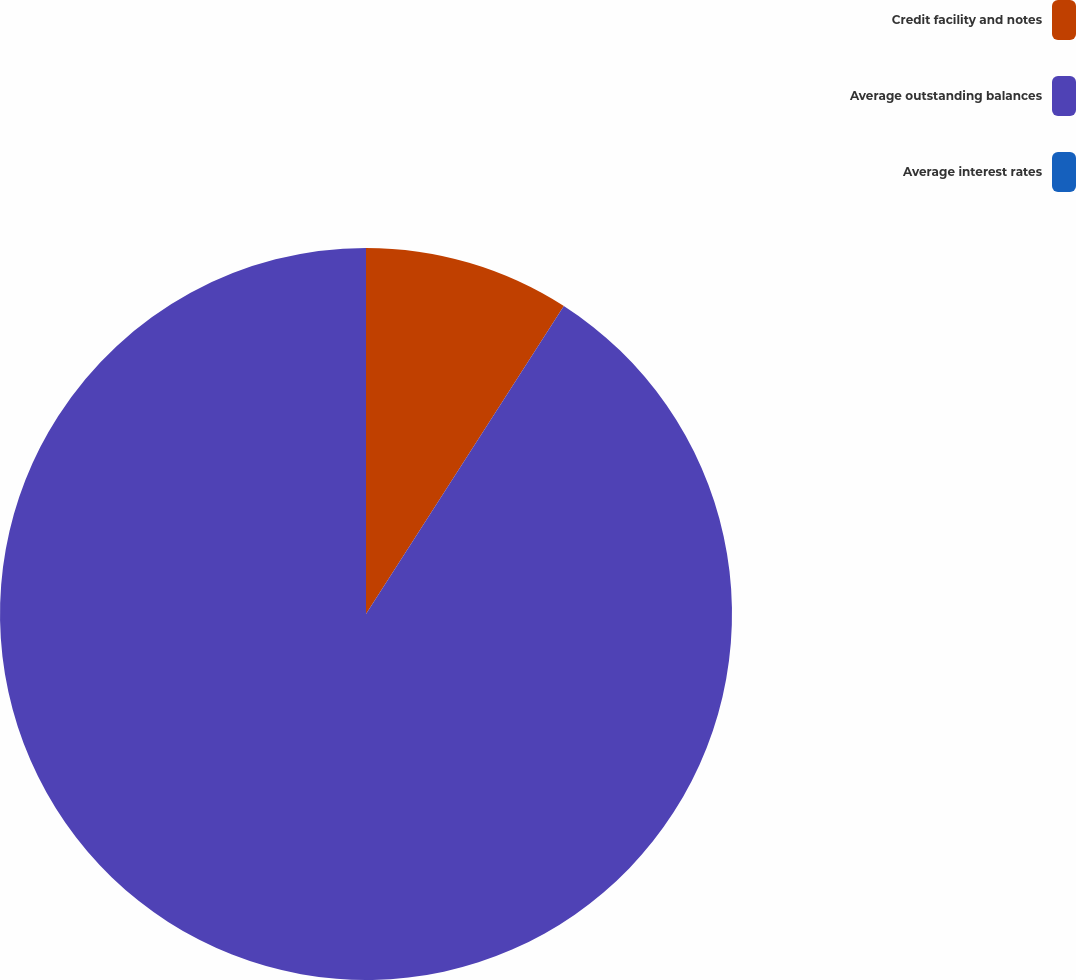Convert chart. <chart><loc_0><loc_0><loc_500><loc_500><pie_chart><fcel>Credit facility and notes<fcel>Average outstanding balances<fcel>Average interest rates<nl><fcel>9.09%<fcel>90.91%<fcel>0.0%<nl></chart> 